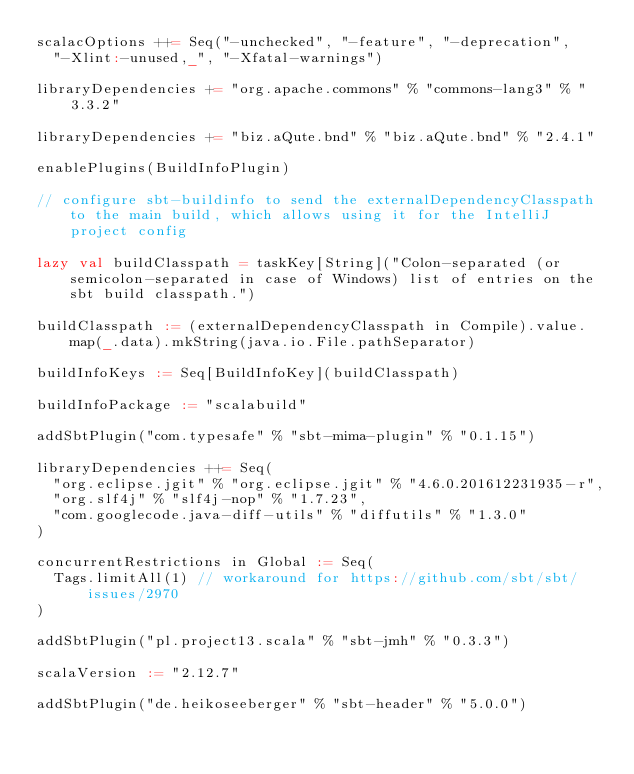Convert code to text. <code><loc_0><loc_0><loc_500><loc_500><_Scala_>scalacOptions ++= Seq("-unchecked", "-feature", "-deprecation",
  "-Xlint:-unused,_", "-Xfatal-warnings")

libraryDependencies += "org.apache.commons" % "commons-lang3" % "3.3.2"

libraryDependencies += "biz.aQute.bnd" % "biz.aQute.bnd" % "2.4.1"

enablePlugins(BuildInfoPlugin)

// configure sbt-buildinfo to send the externalDependencyClasspath to the main build, which allows using it for the IntelliJ project config

lazy val buildClasspath = taskKey[String]("Colon-separated (or semicolon-separated in case of Windows) list of entries on the sbt build classpath.")

buildClasspath := (externalDependencyClasspath in Compile).value.map(_.data).mkString(java.io.File.pathSeparator)

buildInfoKeys := Seq[BuildInfoKey](buildClasspath)

buildInfoPackage := "scalabuild"

addSbtPlugin("com.typesafe" % "sbt-mima-plugin" % "0.1.15")

libraryDependencies ++= Seq(
  "org.eclipse.jgit" % "org.eclipse.jgit" % "4.6.0.201612231935-r",
  "org.slf4j" % "slf4j-nop" % "1.7.23",
  "com.googlecode.java-diff-utils" % "diffutils" % "1.3.0"
)

concurrentRestrictions in Global := Seq(
  Tags.limitAll(1) // workaround for https://github.com/sbt/sbt/issues/2970
)

addSbtPlugin("pl.project13.scala" % "sbt-jmh" % "0.3.3")

scalaVersion := "2.12.7"

addSbtPlugin("de.heikoseeberger" % "sbt-header" % "5.0.0")
</code> 